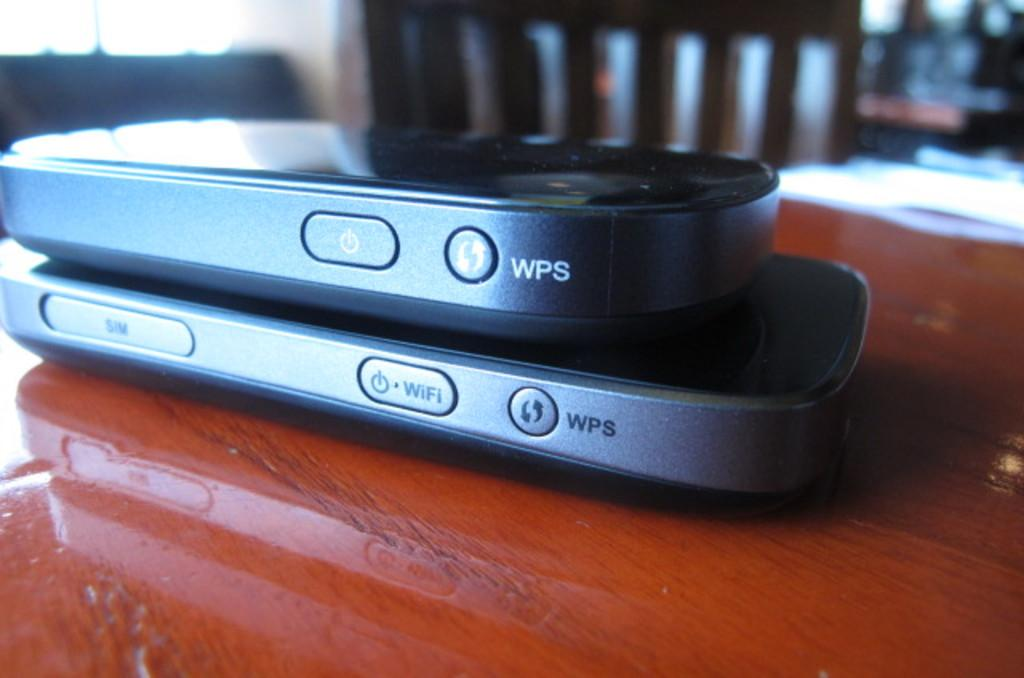<image>
Relay a brief, clear account of the picture shown. Two WPS brand devices stacked on top of each other. 